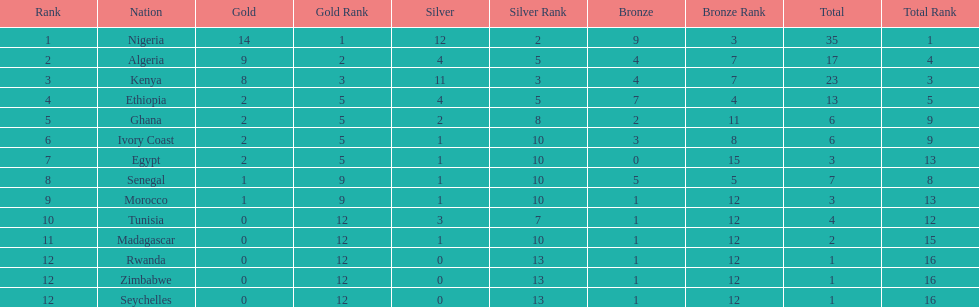Which nations have won only one medal? Rwanda, Zimbabwe, Seychelles. 